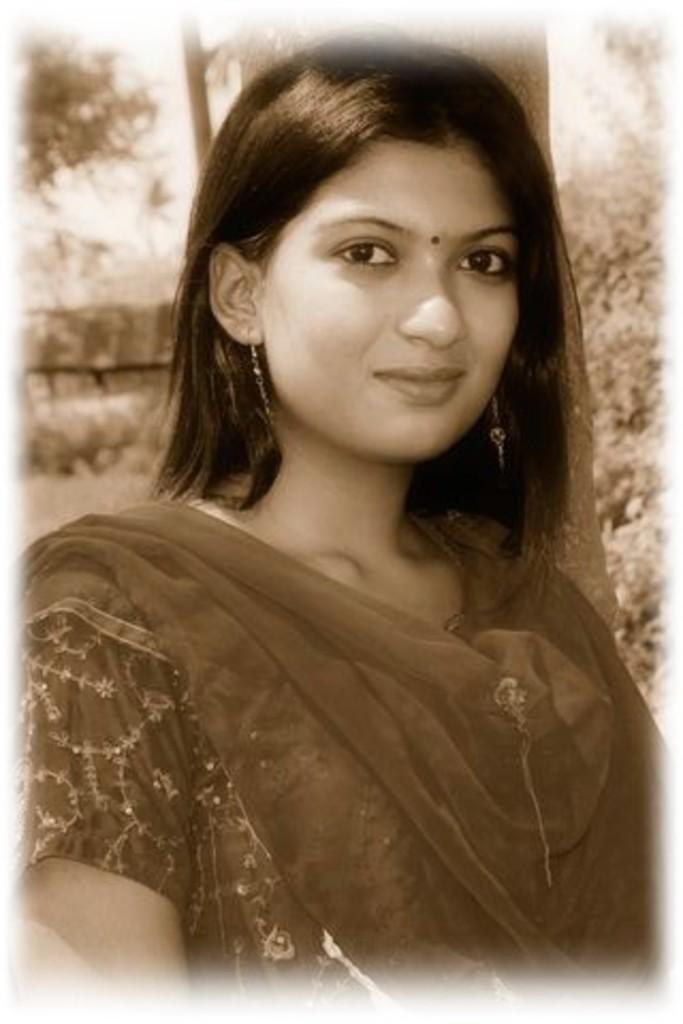What is the color scheme of the image? The image is black and white. Who is present in the image? There is a woman in the image. What is the woman's expression in the image? The woman is smiling in the image. What can be seen in the background of the image? There are trees in the background of the image. Can you hear the bell ringing in the image? There is no bell present in the image, so it cannot be heard. 